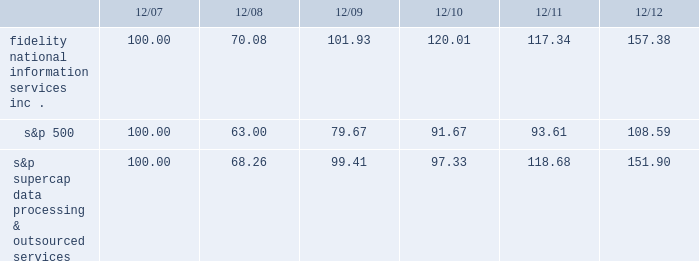
S&p supercap data processing & outsourced 100.00 68.26 99.41 97.33 118.68 151.90 item 6 .
Selected financial data .
The selected financial data set forth below constitutes historical financial data of fis and should be read in conjunction with item 7 , management 2019s discussion and analysis of financial condition and results of operations , and item 8 , financial statements and supplementary data , included elsewhere in this report .
On october 1 , 2009 , we completed the acquisition of metavante technologies , inc .
( "metavante" ) .
The results of operations and financial position of metavante are included in the consolidated financial statements since the date of acquisition .
On july 2 , 2008 , we completed the spin-off of lender processing services , inc. , which was a former wholly-owned subsidiary ( "lps" ) .
For accounting purposes , the results of lps are presented as discontinued operations .
Accordingly , all prior periods have been restated to present the results of fis on a stand alone basis and include the results of lps up to july 2 , 2008 , as discontinued operations. .
What was the difference in percentage cumulative 5-year total shareholder return on common stock fidelity national information services , inc . compared to the s&p 500 for the period ending 12/16? 
Computations: (((157.38 - 100) / 100) - ((108.59 - 100) / 100))
Answer: 0.4879. 